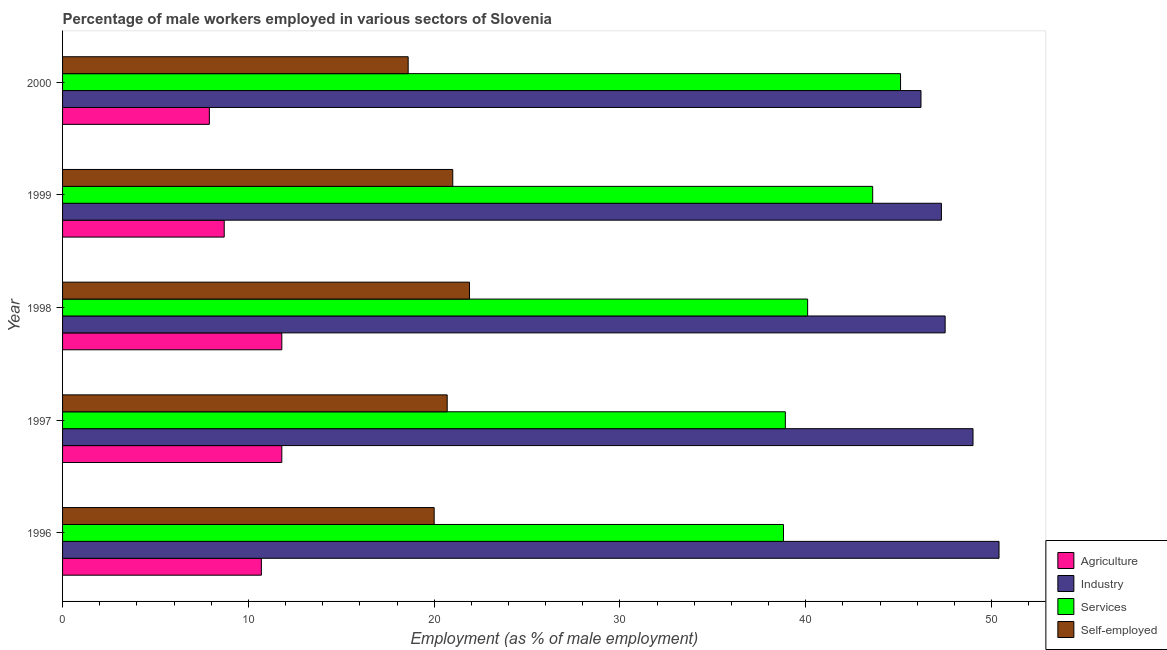How many different coloured bars are there?
Your answer should be very brief. 4. Are the number of bars on each tick of the Y-axis equal?
Make the answer very short. Yes. How many bars are there on the 3rd tick from the top?
Offer a very short reply. 4. In how many cases, is the number of bars for a given year not equal to the number of legend labels?
Your response must be concise. 0. What is the percentage of male workers in agriculture in 1998?
Your response must be concise. 11.8. Across all years, what is the maximum percentage of male workers in agriculture?
Keep it short and to the point. 11.8. Across all years, what is the minimum percentage of male workers in services?
Offer a very short reply. 38.8. What is the total percentage of male workers in services in the graph?
Your response must be concise. 206.5. What is the difference between the percentage of self employed male workers in 2000 and the percentage of male workers in industry in 1996?
Your response must be concise. -31.8. What is the average percentage of male workers in industry per year?
Keep it short and to the point. 48.08. In the year 1996, what is the difference between the percentage of male workers in agriculture and percentage of male workers in industry?
Your answer should be very brief. -39.7. What is the ratio of the percentage of male workers in services in 1998 to that in 2000?
Give a very brief answer. 0.89. Is the percentage of male workers in agriculture in 1996 less than that in 2000?
Make the answer very short. No. What is the difference between the highest and the second highest percentage of male workers in services?
Make the answer very short. 1.5. What does the 2nd bar from the top in 1997 represents?
Your answer should be very brief. Services. What does the 3rd bar from the bottom in 1997 represents?
Ensure brevity in your answer.  Services. Is it the case that in every year, the sum of the percentage of male workers in agriculture and percentage of male workers in industry is greater than the percentage of male workers in services?
Make the answer very short. Yes. How many bars are there?
Offer a very short reply. 20. Are all the bars in the graph horizontal?
Keep it short and to the point. Yes. How many years are there in the graph?
Your answer should be very brief. 5. Are the values on the major ticks of X-axis written in scientific E-notation?
Provide a succinct answer. No. Does the graph contain any zero values?
Your response must be concise. No. What is the title of the graph?
Give a very brief answer. Percentage of male workers employed in various sectors of Slovenia. What is the label or title of the X-axis?
Make the answer very short. Employment (as % of male employment). What is the label or title of the Y-axis?
Keep it short and to the point. Year. What is the Employment (as % of male employment) in Agriculture in 1996?
Keep it short and to the point. 10.7. What is the Employment (as % of male employment) of Industry in 1996?
Ensure brevity in your answer.  50.4. What is the Employment (as % of male employment) in Services in 1996?
Provide a succinct answer. 38.8. What is the Employment (as % of male employment) in Agriculture in 1997?
Provide a succinct answer. 11.8. What is the Employment (as % of male employment) in Industry in 1997?
Your response must be concise. 49. What is the Employment (as % of male employment) in Services in 1997?
Give a very brief answer. 38.9. What is the Employment (as % of male employment) in Self-employed in 1997?
Provide a succinct answer. 20.7. What is the Employment (as % of male employment) in Agriculture in 1998?
Provide a short and direct response. 11.8. What is the Employment (as % of male employment) in Industry in 1998?
Your response must be concise. 47.5. What is the Employment (as % of male employment) of Services in 1998?
Your answer should be compact. 40.1. What is the Employment (as % of male employment) in Self-employed in 1998?
Ensure brevity in your answer.  21.9. What is the Employment (as % of male employment) of Agriculture in 1999?
Your answer should be compact. 8.7. What is the Employment (as % of male employment) in Industry in 1999?
Keep it short and to the point. 47.3. What is the Employment (as % of male employment) of Services in 1999?
Keep it short and to the point. 43.6. What is the Employment (as % of male employment) in Self-employed in 1999?
Provide a short and direct response. 21. What is the Employment (as % of male employment) in Agriculture in 2000?
Keep it short and to the point. 7.9. What is the Employment (as % of male employment) in Industry in 2000?
Your answer should be very brief. 46.2. What is the Employment (as % of male employment) of Services in 2000?
Provide a succinct answer. 45.1. What is the Employment (as % of male employment) in Self-employed in 2000?
Your answer should be very brief. 18.6. Across all years, what is the maximum Employment (as % of male employment) in Agriculture?
Keep it short and to the point. 11.8. Across all years, what is the maximum Employment (as % of male employment) in Industry?
Give a very brief answer. 50.4. Across all years, what is the maximum Employment (as % of male employment) of Services?
Provide a succinct answer. 45.1. Across all years, what is the maximum Employment (as % of male employment) of Self-employed?
Give a very brief answer. 21.9. Across all years, what is the minimum Employment (as % of male employment) of Agriculture?
Your response must be concise. 7.9. Across all years, what is the minimum Employment (as % of male employment) of Industry?
Make the answer very short. 46.2. Across all years, what is the minimum Employment (as % of male employment) in Services?
Make the answer very short. 38.8. Across all years, what is the minimum Employment (as % of male employment) in Self-employed?
Make the answer very short. 18.6. What is the total Employment (as % of male employment) of Agriculture in the graph?
Provide a succinct answer. 50.9. What is the total Employment (as % of male employment) in Industry in the graph?
Your answer should be compact. 240.4. What is the total Employment (as % of male employment) in Services in the graph?
Ensure brevity in your answer.  206.5. What is the total Employment (as % of male employment) of Self-employed in the graph?
Your response must be concise. 102.2. What is the difference between the Employment (as % of male employment) in Industry in 1996 and that in 1997?
Your answer should be compact. 1.4. What is the difference between the Employment (as % of male employment) in Agriculture in 1996 and that in 1998?
Your answer should be very brief. -1.1. What is the difference between the Employment (as % of male employment) in Industry in 1996 and that in 1998?
Your answer should be compact. 2.9. What is the difference between the Employment (as % of male employment) in Services in 1996 and that in 1998?
Offer a terse response. -1.3. What is the difference between the Employment (as % of male employment) of Services in 1996 and that in 1999?
Offer a very short reply. -4.8. What is the difference between the Employment (as % of male employment) of Self-employed in 1996 and that in 1999?
Ensure brevity in your answer.  -1. What is the difference between the Employment (as % of male employment) of Industry in 1996 and that in 2000?
Your answer should be compact. 4.2. What is the difference between the Employment (as % of male employment) in Services in 1996 and that in 2000?
Your response must be concise. -6.3. What is the difference between the Employment (as % of male employment) in Self-employed in 1996 and that in 2000?
Your answer should be very brief. 1.4. What is the difference between the Employment (as % of male employment) of Agriculture in 1997 and that in 1998?
Offer a very short reply. 0. What is the difference between the Employment (as % of male employment) of Industry in 1997 and that in 1998?
Make the answer very short. 1.5. What is the difference between the Employment (as % of male employment) of Self-employed in 1997 and that in 1998?
Provide a short and direct response. -1.2. What is the difference between the Employment (as % of male employment) in Industry in 1997 and that in 1999?
Your answer should be very brief. 1.7. What is the difference between the Employment (as % of male employment) in Services in 1997 and that in 1999?
Provide a succinct answer. -4.7. What is the difference between the Employment (as % of male employment) of Agriculture in 1997 and that in 2000?
Provide a succinct answer. 3.9. What is the difference between the Employment (as % of male employment) of Services in 1997 and that in 2000?
Ensure brevity in your answer.  -6.2. What is the difference between the Employment (as % of male employment) in Industry in 1998 and that in 1999?
Your answer should be compact. 0.2. What is the difference between the Employment (as % of male employment) of Services in 1998 and that in 1999?
Offer a very short reply. -3.5. What is the difference between the Employment (as % of male employment) in Agriculture in 1998 and that in 2000?
Keep it short and to the point. 3.9. What is the difference between the Employment (as % of male employment) in Industry in 1998 and that in 2000?
Give a very brief answer. 1.3. What is the difference between the Employment (as % of male employment) of Services in 1999 and that in 2000?
Your response must be concise. -1.5. What is the difference between the Employment (as % of male employment) in Self-employed in 1999 and that in 2000?
Make the answer very short. 2.4. What is the difference between the Employment (as % of male employment) in Agriculture in 1996 and the Employment (as % of male employment) in Industry in 1997?
Keep it short and to the point. -38.3. What is the difference between the Employment (as % of male employment) of Agriculture in 1996 and the Employment (as % of male employment) of Services in 1997?
Provide a short and direct response. -28.2. What is the difference between the Employment (as % of male employment) of Agriculture in 1996 and the Employment (as % of male employment) of Self-employed in 1997?
Give a very brief answer. -10. What is the difference between the Employment (as % of male employment) in Industry in 1996 and the Employment (as % of male employment) in Services in 1997?
Give a very brief answer. 11.5. What is the difference between the Employment (as % of male employment) of Industry in 1996 and the Employment (as % of male employment) of Self-employed in 1997?
Offer a very short reply. 29.7. What is the difference between the Employment (as % of male employment) of Services in 1996 and the Employment (as % of male employment) of Self-employed in 1997?
Ensure brevity in your answer.  18.1. What is the difference between the Employment (as % of male employment) of Agriculture in 1996 and the Employment (as % of male employment) of Industry in 1998?
Offer a terse response. -36.8. What is the difference between the Employment (as % of male employment) in Agriculture in 1996 and the Employment (as % of male employment) in Services in 1998?
Make the answer very short. -29.4. What is the difference between the Employment (as % of male employment) in Agriculture in 1996 and the Employment (as % of male employment) in Self-employed in 1998?
Your answer should be very brief. -11.2. What is the difference between the Employment (as % of male employment) of Industry in 1996 and the Employment (as % of male employment) of Services in 1998?
Give a very brief answer. 10.3. What is the difference between the Employment (as % of male employment) of Services in 1996 and the Employment (as % of male employment) of Self-employed in 1998?
Give a very brief answer. 16.9. What is the difference between the Employment (as % of male employment) in Agriculture in 1996 and the Employment (as % of male employment) in Industry in 1999?
Give a very brief answer. -36.6. What is the difference between the Employment (as % of male employment) in Agriculture in 1996 and the Employment (as % of male employment) in Services in 1999?
Offer a very short reply. -32.9. What is the difference between the Employment (as % of male employment) in Industry in 1996 and the Employment (as % of male employment) in Self-employed in 1999?
Offer a very short reply. 29.4. What is the difference between the Employment (as % of male employment) in Agriculture in 1996 and the Employment (as % of male employment) in Industry in 2000?
Provide a succinct answer. -35.5. What is the difference between the Employment (as % of male employment) in Agriculture in 1996 and the Employment (as % of male employment) in Services in 2000?
Provide a short and direct response. -34.4. What is the difference between the Employment (as % of male employment) in Agriculture in 1996 and the Employment (as % of male employment) in Self-employed in 2000?
Provide a short and direct response. -7.9. What is the difference between the Employment (as % of male employment) of Industry in 1996 and the Employment (as % of male employment) of Services in 2000?
Ensure brevity in your answer.  5.3. What is the difference between the Employment (as % of male employment) in Industry in 1996 and the Employment (as % of male employment) in Self-employed in 2000?
Make the answer very short. 31.8. What is the difference between the Employment (as % of male employment) in Services in 1996 and the Employment (as % of male employment) in Self-employed in 2000?
Your response must be concise. 20.2. What is the difference between the Employment (as % of male employment) in Agriculture in 1997 and the Employment (as % of male employment) in Industry in 1998?
Provide a short and direct response. -35.7. What is the difference between the Employment (as % of male employment) in Agriculture in 1997 and the Employment (as % of male employment) in Services in 1998?
Your answer should be compact. -28.3. What is the difference between the Employment (as % of male employment) in Industry in 1997 and the Employment (as % of male employment) in Services in 1998?
Keep it short and to the point. 8.9. What is the difference between the Employment (as % of male employment) of Industry in 1997 and the Employment (as % of male employment) of Self-employed in 1998?
Give a very brief answer. 27.1. What is the difference between the Employment (as % of male employment) in Agriculture in 1997 and the Employment (as % of male employment) in Industry in 1999?
Your response must be concise. -35.5. What is the difference between the Employment (as % of male employment) of Agriculture in 1997 and the Employment (as % of male employment) of Services in 1999?
Provide a succinct answer. -31.8. What is the difference between the Employment (as % of male employment) of Industry in 1997 and the Employment (as % of male employment) of Self-employed in 1999?
Your answer should be very brief. 28. What is the difference between the Employment (as % of male employment) of Services in 1997 and the Employment (as % of male employment) of Self-employed in 1999?
Provide a succinct answer. 17.9. What is the difference between the Employment (as % of male employment) in Agriculture in 1997 and the Employment (as % of male employment) in Industry in 2000?
Your answer should be very brief. -34.4. What is the difference between the Employment (as % of male employment) of Agriculture in 1997 and the Employment (as % of male employment) of Services in 2000?
Your answer should be compact. -33.3. What is the difference between the Employment (as % of male employment) of Agriculture in 1997 and the Employment (as % of male employment) of Self-employed in 2000?
Give a very brief answer. -6.8. What is the difference between the Employment (as % of male employment) in Industry in 1997 and the Employment (as % of male employment) in Self-employed in 2000?
Provide a succinct answer. 30.4. What is the difference between the Employment (as % of male employment) of Services in 1997 and the Employment (as % of male employment) of Self-employed in 2000?
Make the answer very short. 20.3. What is the difference between the Employment (as % of male employment) in Agriculture in 1998 and the Employment (as % of male employment) in Industry in 1999?
Provide a short and direct response. -35.5. What is the difference between the Employment (as % of male employment) of Agriculture in 1998 and the Employment (as % of male employment) of Services in 1999?
Offer a very short reply. -31.8. What is the difference between the Employment (as % of male employment) in Agriculture in 1998 and the Employment (as % of male employment) in Self-employed in 1999?
Offer a terse response. -9.2. What is the difference between the Employment (as % of male employment) of Industry in 1998 and the Employment (as % of male employment) of Self-employed in 1999?
Offer a terse response. 26.5. What is the difference between the Employment (as % of male employment) in Agriculture in 1998 and the Employment (as % of male employment) in Industry in 2000?
Provide a short and direct response. -34.4. What is the difference between the Employment (as % of male employment) of Agriculture in 1998 and the Employment (as % of male employment) of Services in 2000?
Your answer should be compact. -33.3. What is the difference between the Employment (as % of male employment) of Agriculture in 1998 and the Employment (as % of male employment) of Self-employed in 2000?
Provide a short and direct response. -6.8. What is the difference between the Employment (as % of male employment) of Industry in 1998 and the Employment (as % of male employment) of Services in 2000?
Make the answer very short. 2.4. What is the difference between the Employment (as % of male employment) in Industry in 1998 and the Employment (as % of male employment) in Self-employed in 2000?
Offer a very short reply. 28.9. What is the difference between the Employment (as % of male employment) in Services in 1998 and the Employment (as % of male employment) in Self-employed in 2000?
Ensure brevity in your answer.  21.5. What is the difference between the Employment (as % of male employment) in Agriculture in 1999 and the Employment (as % of male employment) in Industry in 2000?
Your answer should be very brief. -37.5. What is the difference between the Employment (as % of male employment) in Agriculture in 1999 and the Employment (as % of male employment) in Services in 2000?
Your answer should be very brief. -36.4. What is the difference between the Employment (as % of male employment) in Industry in 1999 and the Employment (as % of male employment) in Services in 2000?
Offer a very short reply. 2.2. What is the difference between the Employment (as % of male employment) of Industry in 1999 and the Employment (as % of male employment) of Self-employed in 2000?
Keep it short and to the point. 28.7. What is the difference between the Employment (as % of male employment) of Services in 1999 and the Employment (as % of male employment) of Self-employed in 2000?
Provide a short and direct response. 25. What is the average Employment (as % of male employment) in Agriculture per year?
Keep it short and to the point. 10.18. What is the average Employment (as % of male employment) of Industry per year?
Your answer should be compact. 48.08. What is the average Employment (as % of male employment) of Services per year?
Offer a very short reply. 41.3. What is the average Employment (as % of male employment) in Self-employed per year?
Give a very brief answer. 20.44. In the year 1996, what is the difference between the Employment (as % of male employment) in Agriculture and Employment (as % of male employment) in Industry?
Keep it short and to the point. -39.7. In the year 1996, what is the difference between the Employment (as % of male employment) of Agriculture and Employment (as % of male employment) of Services?
Give a very brief answer. -28.1. In the year 1996, what is the difference between the Employment (as % of male employment) of Industry and Employment (as % of male employment) of Self-employed?
Offer a very short reply. 30.4. In the year 1997, what is the difference between the Employment (as % of male employment) of Agriculture and Employment (as % of male employment) of Industry?
Provide a short and direct response. -37.2. In the year 1997, what is the difference between the Employment (as % of male employment) in Agriculture and Employment (as % of male employment) in Services?
Ensure brevity in your answer.  -27.1. In the year 1997, what is the difference between the Employment (as % of male employment) in Agriculture and Employment (as % of male employment) in Self-employed?
Your answer should be very brief. -8.9. In the year 1997, what is the difference between the Employment (as % of male employment) of Industry and Employment (as % of male employment) of Services?
Make the answer very short. 10.1. In the year 1997, what is the difference between the Employment (as % of male employment) in Industry and Employment (as % of male employment) in Self-employed?
Offer a terse response. 28.3. In the year 1997, what is the difference between the Employment (as % of male employment) of Services and Employment (as % of male employment) of Self-employed?
Provide a short and direct response. 18.2. In the year 1998, what is the difference between the Employment (as % of male employment) in Agriculture and Employment (as % of male employment) in Industry?
Offer a terse response. -35.7. In the year 1998, what is the difference between the Employment (as % of male employment) in Agriculture and Employment (as % of male employment) in Services?
Ensure brevity in your answer.  -28.3. In the year 1998, what is the difference between the Employment (as % of male employment) of Industry and Employment (as % of male employment) of Services?
Ensure brevity in your answer.  7.4. In the year 1998, what is the difference between the Employment (as % of male employment) of Industry and Employment (as % of male employment) of Self-employed?
Your response must be concise. 25.6. In the year 1998, what is the difference between the Employment (as % of male employment) in Services and Employment (as % of male employment) in Self-employed?
Your answer should be very brief. 18.2. In the year 1999, what is the difference between the Employment (as % of male employment) in Agriculture and Employment (as % of male employment) in Industry?
Your response must be concise. -38.6. In the year 1999, what is the difference between the Employment (as % of male employment) of Agriculture and Employment (as % of male employment) of Services?
Your response must be concise. -34.9. In the year 1999, what is the difference between the Employment (as % of male employment) in Industry and Employment (as % of male employment) in Services?
Your answer should be very brief. 3.7. In the year 1999, what is the difference between the Employment (as % of male employment) in Industry and Employment (as % of male employment) in Self-employed?
Offer a very short reply. 26.3. In the year 1999, what is the difference between the Employment (as % of male employment) in Services and Employment (as % of male employment) in Self-employed?
Offer a very short reply. 22.6. In the year 2000, what is the difference between the Employment (as % of male employment) of Agriculture and Employment (as % of male employment) of Industry?
Keep it short and to the point. -38.3. In the year 2000, what is the difference between the Employment (as % of male employment) of Agriculture and Employment (as % of male employment) of Services?
Give a very brief answer. -37.2. In the year 2000, what is the difference between the Employment (as % of male employment) of Industry and Employment (as % of male employment) of Services?
Keep it short and to the point. 1.1. In the year 2000, what is the difference between the Employment (as % of male employment) in Industry and Employment (as % of male employment) in Self-employed?
Offer a terse response. 27.6. In the year 2000, what is the difference between the Employment (as % of male employment) in Services and Employment (as % of male employment) in Self-employed?
Offer a terse response. 26.5. What is the ratio of the Employment (as % of male employment) in Agriculture in 1996 to that in 1997?
Offer a terse response. 0.91. What is the ratio of the Employment (as % of male employment) in Industry in 1996 to that in 1997?
Keep it short and to the point. 1.03. What is the ratio of the Employment (as % of male employment) of Self-employed in 1996 to that in 1997?
Offer a very short reply. 0.97. What is the ratio of the Employment (as % of male employment) in Agriculture in 1996 to that in 1998?
Your response must be concise. 0.91. What is the ratio of the Employment (as % of male employment) of Industry in 1996 to that in 1998?
Make the answer very short. 1.06. What is the ratio of the Employment (as % of male employment) in Services in 1996 to that in 1998?
Ensure brevity in your answer.  0.97. What is the ratio of the Employment (as % of male employment) in Self-employed in 1996 to that in 1998?
Your response must be concise. 0.91. What is the ratio of the Employment (as % of male employment) in Agriculture in 1996 to that in 1999?
Give a very brief answer. 1.23. What is the ratio of the Employment (as % of male employment) of Industry in 1996 to that in 1999?
Ensure brevity in your answer.  1.07. What is the ratio of the Employment (as % of male employment) of Services in 1996 to that in 1999?
Your response must be concise. 0.89. What is the ratio of the Employment (as % of male employment) of Agriculture in 1996 to that in 2000?
Offer a terse response. 1.35. What is the ratio of the Employment (as % of male employment) of Services in 1996 to that in 2000?
Your response must be concise. 0.86. What is the ratio of the Employment (as % of male employment) of Self-employed in 1996 to that in 2000?
Give a very brief answer. 1.08. What is the ratio of the Employment (as % of male employment) in Industry in 1997 to that in 1998?
Your answer should be compact. 1.03. What is the ratio of the Employment (as % of male employment) in Services in 1997 to that in 1998?
Keep it short and to the point. 0.97. What is the ratio of the Employment (as % of male employment) in Self-employed in 1997 to that in 1998?
Your answer should be compact. 0.95. What is the ratio of the Employment (as % of male employment) in Agriculture in 1997 to that in 1999?
Make the answer very short. 1.36. What is the ratio of the Employment (as % of male employment) in Industry in 1997 to that in 1999?
Ensure brevity in your answer.  1.04. What is the ratio of the Employment (as % of male employment) of Services in 1997 to that in 1999?
Your answer should be compact. 0.89. What is the ratio of the Employment (as % of male employment) in Self-employed in 1997 to that in 1999?
Your answer should be very brief. 0.99. What is the ratio of the Employment (as % of male employment) in Agriculture in 1997 to that in 2000?
Your answer should be compact. 1.49. What is the ratio of the Employment (as % of male employment) in Industry in 1997 to that in 2000?
Make the answer very short. 1.06. What is the ratio of the Employment (as % of male employment) in Services in 1997 to that in 2000?
Provide a short and direct response. 0.86. What is the ratio of the Employment (as % of male employment) of Self-employed in 1997 to that in 2000?
Your response must be concise. 1.11. What is the ratio of the Employment (as % of male employment) in Agriculture in 1998 to that in 1999?
Keep it short and to the point. 1.36. What is the ratio of the Employment (as % of male employment) in Services in 1998 to that in 1999?
Your response must be concise. 0.92. What is the ratio of the Employment (as % of male employment) of Self-employed in 1998 to that in 1999?
Your answer should be compact. 1.04. What is the ratio of the Employment (as % of male employment) of Agriculture in 1998 to that in 2000?
Provide a succinct answer. 1.49. What is the ratio of the Employment (as % of male employment) of Industry in 1998 to that in 2000?
Your answer should be compact. 1.03. What is the ratio of the Employment (as % of male employment) of Services in 1998 to that in 2000?
Offer a terse response. 0.89. What is the ratio of the Employment (as % of male employment) of Self-employed in 1998 to that in 2000?
Provide a short and direct response. 1.18. What is the ratio of the Employment (as % of male employment) in Agriculture in 1999 to that in 2000?
Make the answer very short. 1.1. What is the ratio of the Employment (as % of male employment) in Industry in 1999 to that in 2000?
Your answer should be very brief. 1.02. What is the ratio of the Employment (as % of male employment) in Services in 1999 to that in 2000?
Ensure brevity in your answer.  0.97. What is the ratio of the Employment (as % of male employment) in Self-employed in 1999 to that in 2000?
Offer a terse response. 1.13. What is the difference between the highest and the second highest Employment (as % of male employment) of Agriculture?
Your answer should be compact. 0. What is the difference between the highest and the lowest Employment (as % of male employment) in Agriculture?
Provide a succinct answer. 3.9. What is the difference between the highest and the lowest Employment (as % of male employment) in Industry?
Offer a terse response. 4.2. What is the difference between the highest and the lowest Employment (as % of male employment) in Services?
Keep it short and to the point. 6.3. What is the difference between the highest and the lowest Employment (as % of male employment) in Self-employed?
Ensure brevity in your answer.  3.3. 